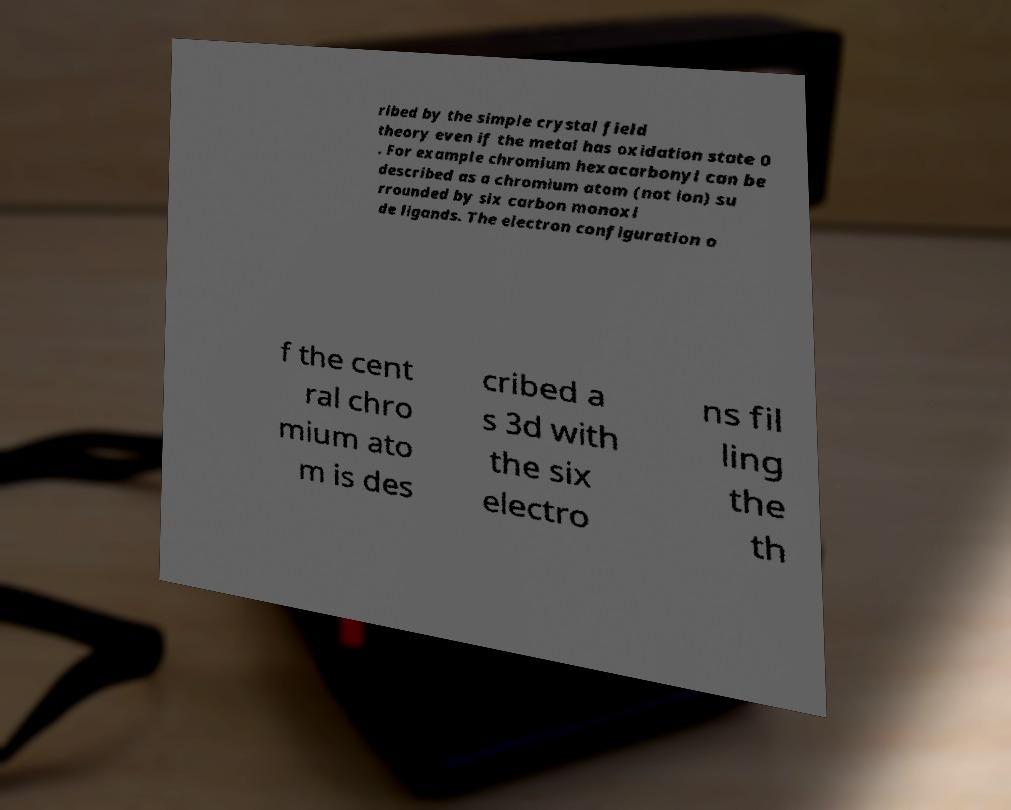Please read and relay the text visible in this image. What does it say? ribed by the simple crystal field theory even if the metal has oxidation state 0 . For example chromium hexacarbonyl can be described as a chromium atom (not ion) su rrounded by six carbon monoxi de ligands. The electron configuration o f the cent ral chro mium ato m is des cribed a s 3d with the six electro ns fil ling the th 